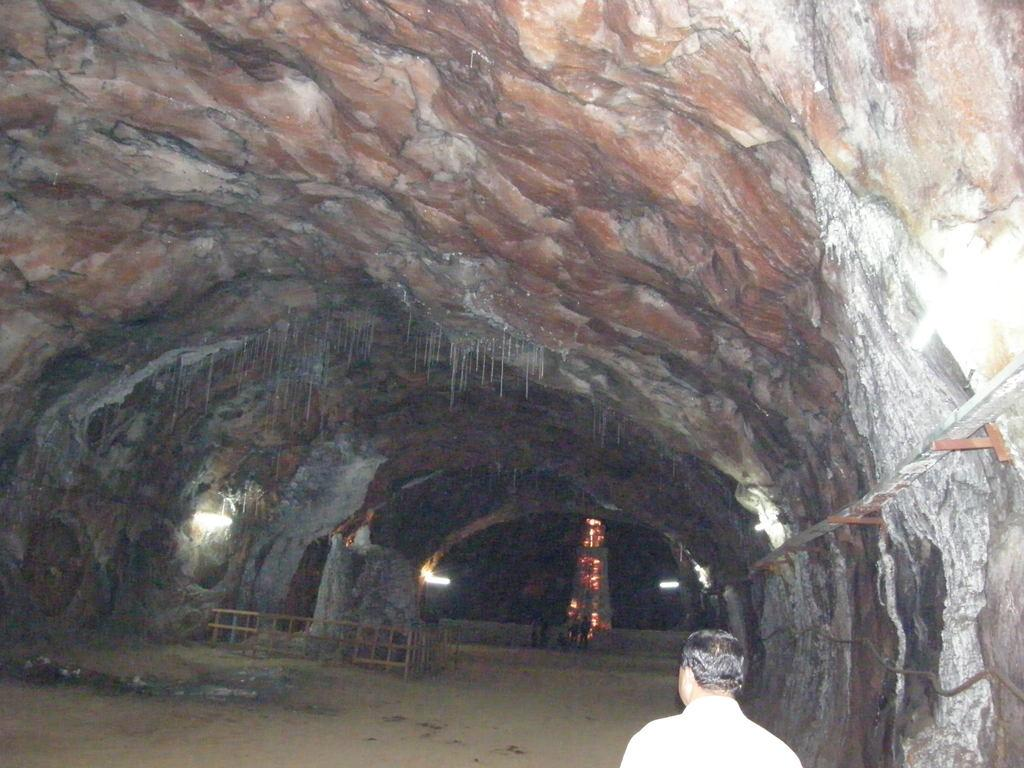Who or what is located at the front of the image? There is a person in the front of the image. What can be seen in the background of the image? There is a tunnel in the background of the image. What features are present within the tunnel? There are lights and a fence in the tunnel. How many cherries are hanging from the fence in the image? There are no cherries present in the image; the tunnel only contains lights and a fence. 